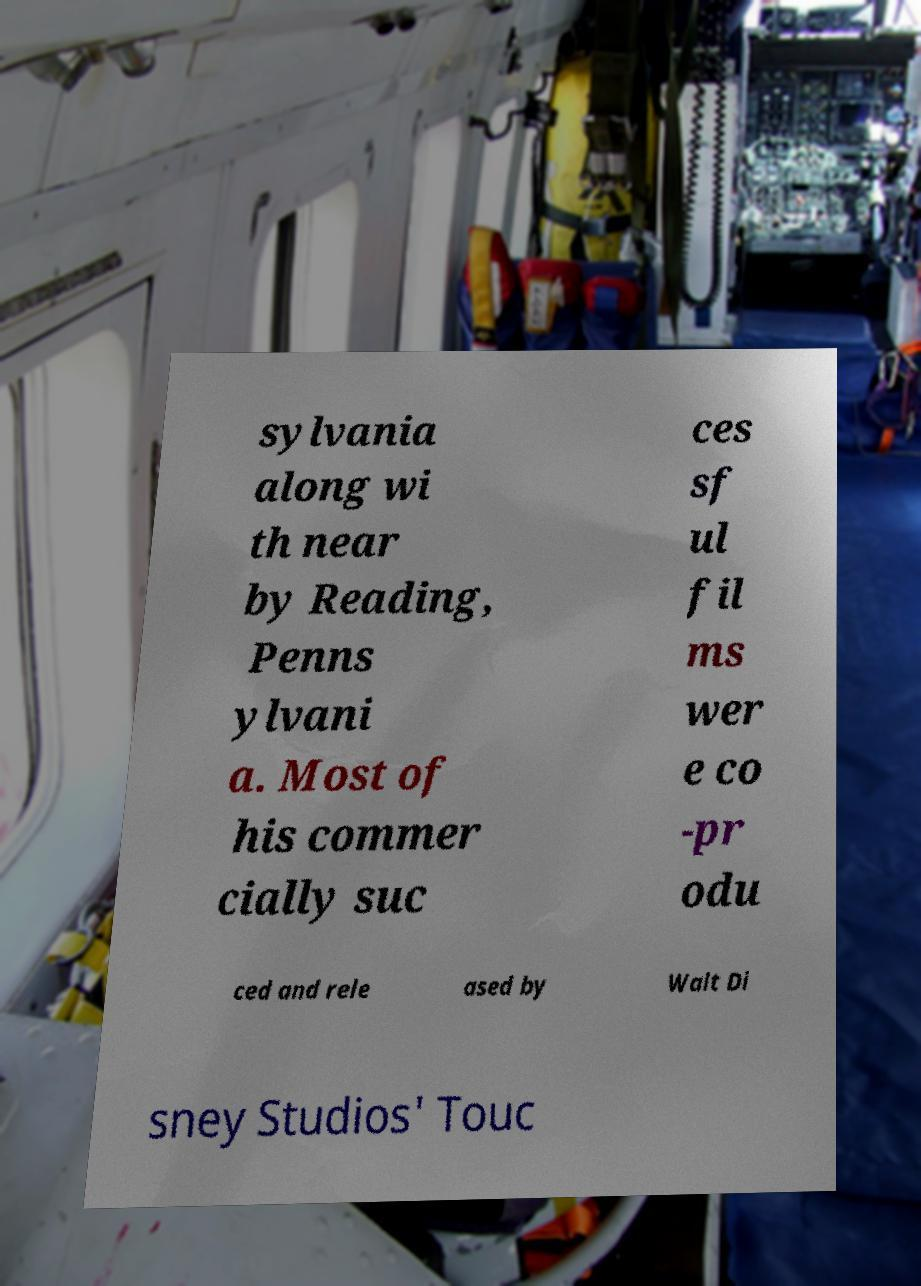Please identify and transcribe the text found in this image. sylvania along wi th near by Reading, Penns ylvani a. Most of his commer cially suc ces sf ul fil ms wer e co -pr odu ced and rele ased by Walt Di sney Studios' Touc 